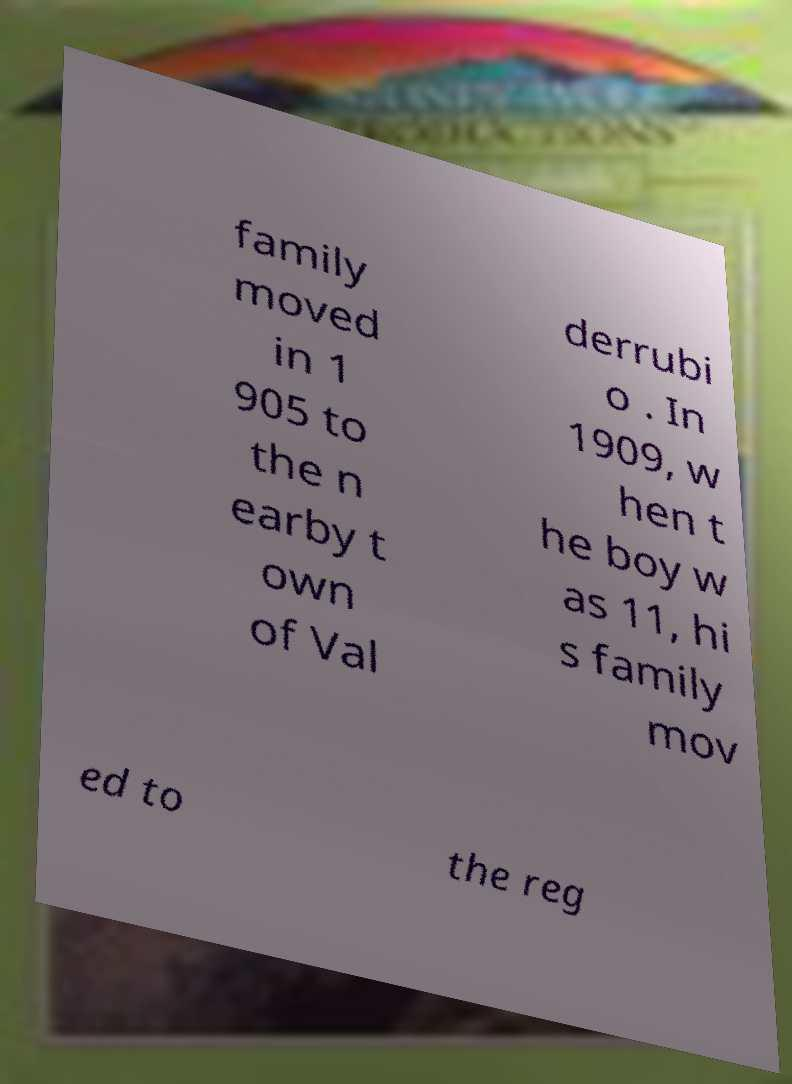Please read and relay the text visible in this image. What does it say? family moved in 1 905 to the n earby t own of Val derrubi o . In 1909, w hen t he boy w as 11, hi s family mov ed to the reg 